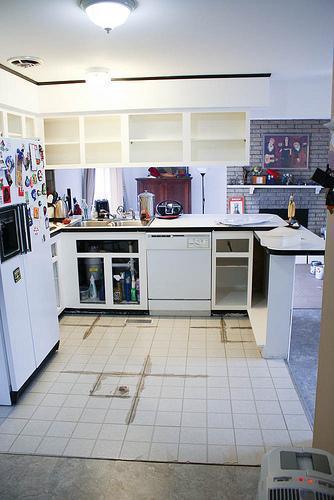How many people are in the picture?
Give a very brief answer. 3. 